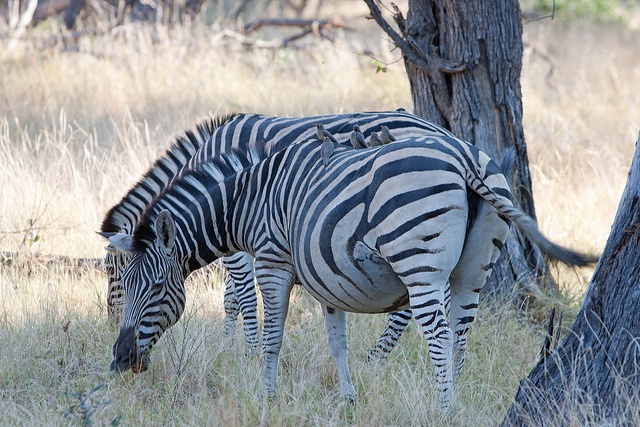Describe the objects in this image and their specific colors. I can see zebra in gray, darkgray, and black tones, zebra in gray, darkgray, and black tones, bird in gray and darkblue tones, bird in gray, blue, and black tones, and bird in gray, black, and navy tones in this image. 